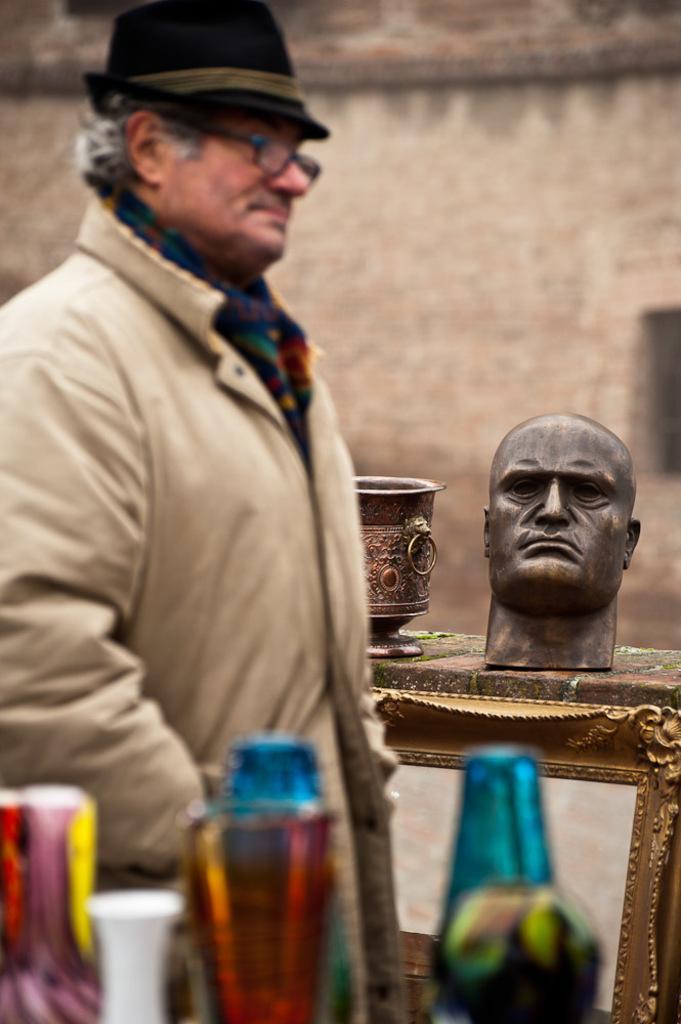Can you describe this image briefly? In this picture I can see colorful things in front and in the middle of this picture I can see a man, who is wearing a coat and a hat on his head and behind him I can see a utensil and a sculpture of a head. In the background I can see the wall. I can also see a frame near to him. 